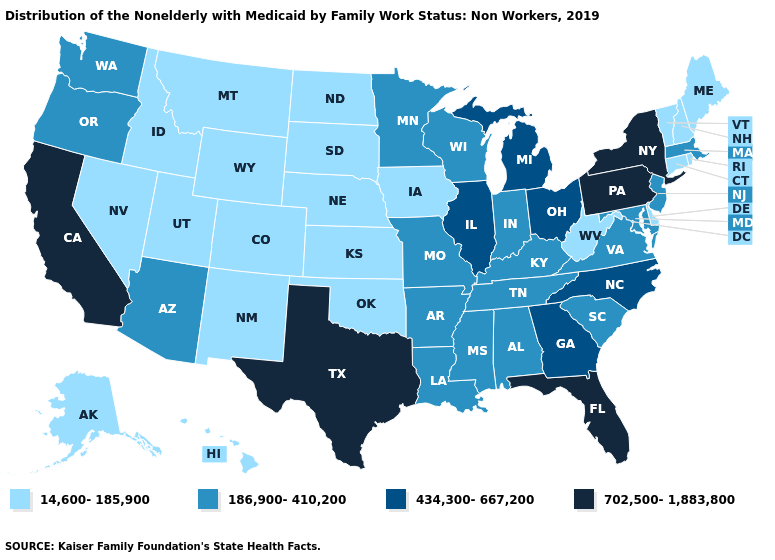Among the states that border Nevada , which have the highest value?
Concise answer only. California. What is the value of Tennessee?
Give a very brief answer. 186,900-410,200. Among the states that border Nevada , does California have the lowest value?
Short answer required. No. Does Maryland have the same value as New Hampshire?
Concise answer only. No. Name the states that have a value in the range 702,500-1,883,800?
Concise answer only. California, Florida, New York, Pennsylvania, Texas. Name the states that have a value in the range 14,600-185,900?
Quick response, please. Alaska, Colorado, Connecticut, Delaware, Hawaii, Idaho, Iowa, Kansas, Maine, Montana, Nebraska, Nevada, New Hampshire, New Mexico, North Dakota, Oklahoma, Rhode Island, South Dakota, Utah, Vermont, West Virginia, Wyoming. Does the first symbol in the legend represent the smallest category?
Concise answer only. Yes. How many symbols are there in the legend?
Answer briefly. 4. Name the states that have a value in the range 186,900-410,200?
Give a very brief answer. Alabama, Arizona, Arkansas, Indiana, Kentucky, Louisiana, Maryland, Massachusetts, Minnesota, Mississippi, Missouri, New Jersey, Oregon, South Carolina, Tennessee, Virginia, Washington, Wisconsin. What is the highest value in the USA?
Be succinct. 702,500-1,883,800. What is the highest value in the South ?
Give a very brief answer. 702,500-1,883,800. Name the states that have a value in the range 186,900-410,200?
Answer briefly. Alabama, Arizona, Arkansas, Indiana, Kentucky, Louisiana, Maryland, Massachusetts, Minnesota, Mississippi, Missouri, New Jersey, Oregon, South Carolina, Tennessee, Virginia, Washington, Wisconsin. Among the states that border Rhode Island , does Connecticut have the lowest value?
Give a very brief answer. Yes. Does Nebraska have the lowest value in the MidWest?
Be succinct. Yes. What is the value of Rhode Island?
Keep it brief. 14,600-185,900. 